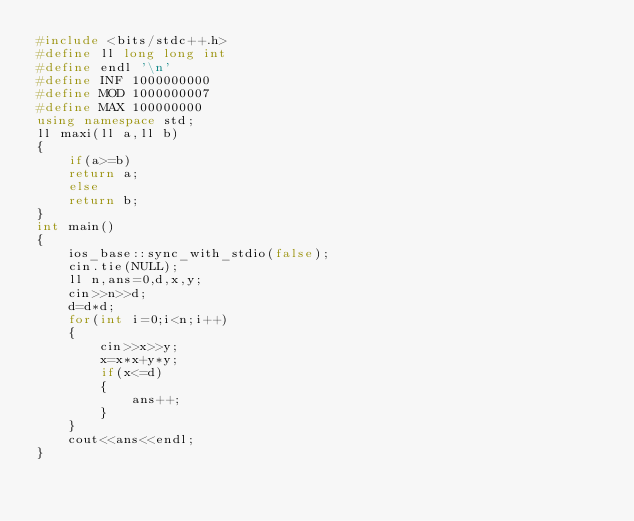Convert code to text. <code><loc_0><loc_0><loc_500><loc_500><_C++_>#include <bits/stdc++.h>
#define ll long long int 
#define endl '\n'
#define INF 1000000000
#define MOD 1000000007
#define MAX 100000000 
using namespace std;
ll maxi(ll a,ll b)
{
	if(a>=b)
	return a;
	else
	return b;
}
int main()
{
	ios_base::sync_with_stdio(false);
    cin.tie(NULL);
    ll n,ans=0,d,x,y;
    cin>>n>>d;
    d=d*d;
    for(int i=0;i<n;i++)
    {
    	cin>>x>>y;
    	x=x*x+y*y;
    	if(x<=d)
    	{
    		ans++;
    	}
    }
    cout<<ans<<endl;
}</code> 